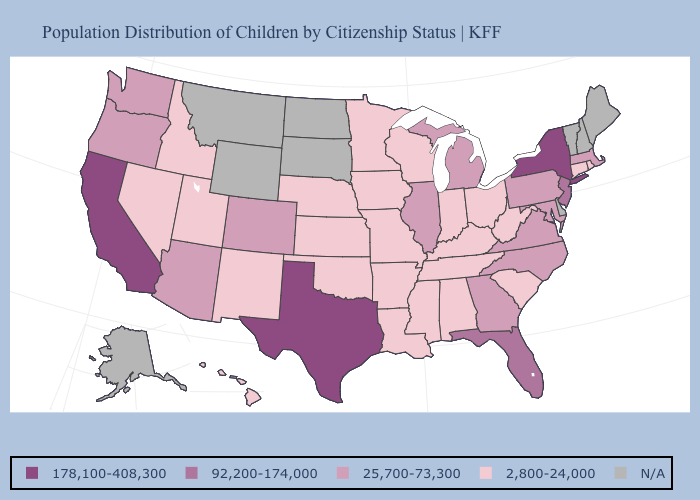Among the states that border Ohio , does Pennsylvania have the highest value?
Keep it brief. Yes. Which states have the highest value in the USA?
Concise answer only. California, New York, Texas. Does Michigan have the highest value in the MidWest?
Write a very short answer. Yes. What is the value of Delaware?
Keep it brief. N/A. Which states hav the highest value in the Northeast?
Be succinct. New York. Among the states that border New Mexico , which have the highest value?
Be succinct. Texas. Among the states that border Connecticut , does Rhode Island have the lowest value?
Answer briefly. Yes. What is the value of Florida?
Give a very brief answer. 92,200-174,000. Name the states that have a value in the range N/A?
Short answer required. Alaska, Delaware, Maine, Montana, New Hampshire, North Dakota, South Dakota, Vermont, Wyoming. Which states have the highest value in the USA?
Answer briefly. California, New York, Texas. Does the first symbol in the legend represent the smallest category?
Be succinct. No. What is the value of South Dakota?
Concise answer only. N/A. What is the highest value in states that border Mississippi?
Write a very short answer. 2,800-24,000. 